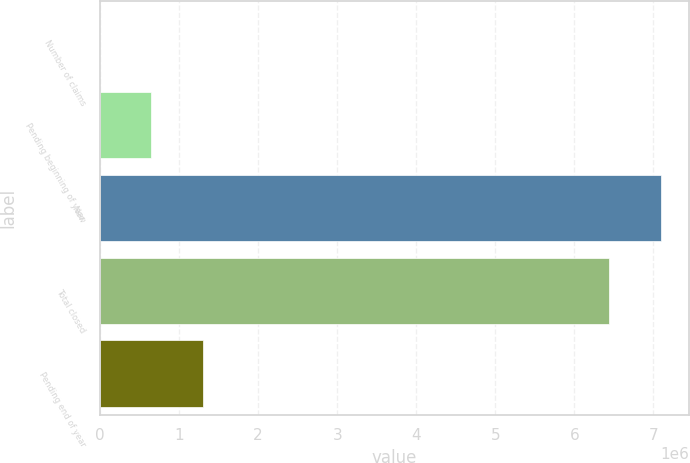Convert chart. <chart><loc_0><loc_0><loc_500><loc_500><bar_chart><fcel>Number of claims<fcel>Pending beginning of year<fcel>New<fcel>Total closed<fcel>Pending end of year<nl><fcel>2018<fcel>651272<fcel>7.09253e+06<fcel>6.44328e+06<fcel>1.30053e+06<nl></chart> 